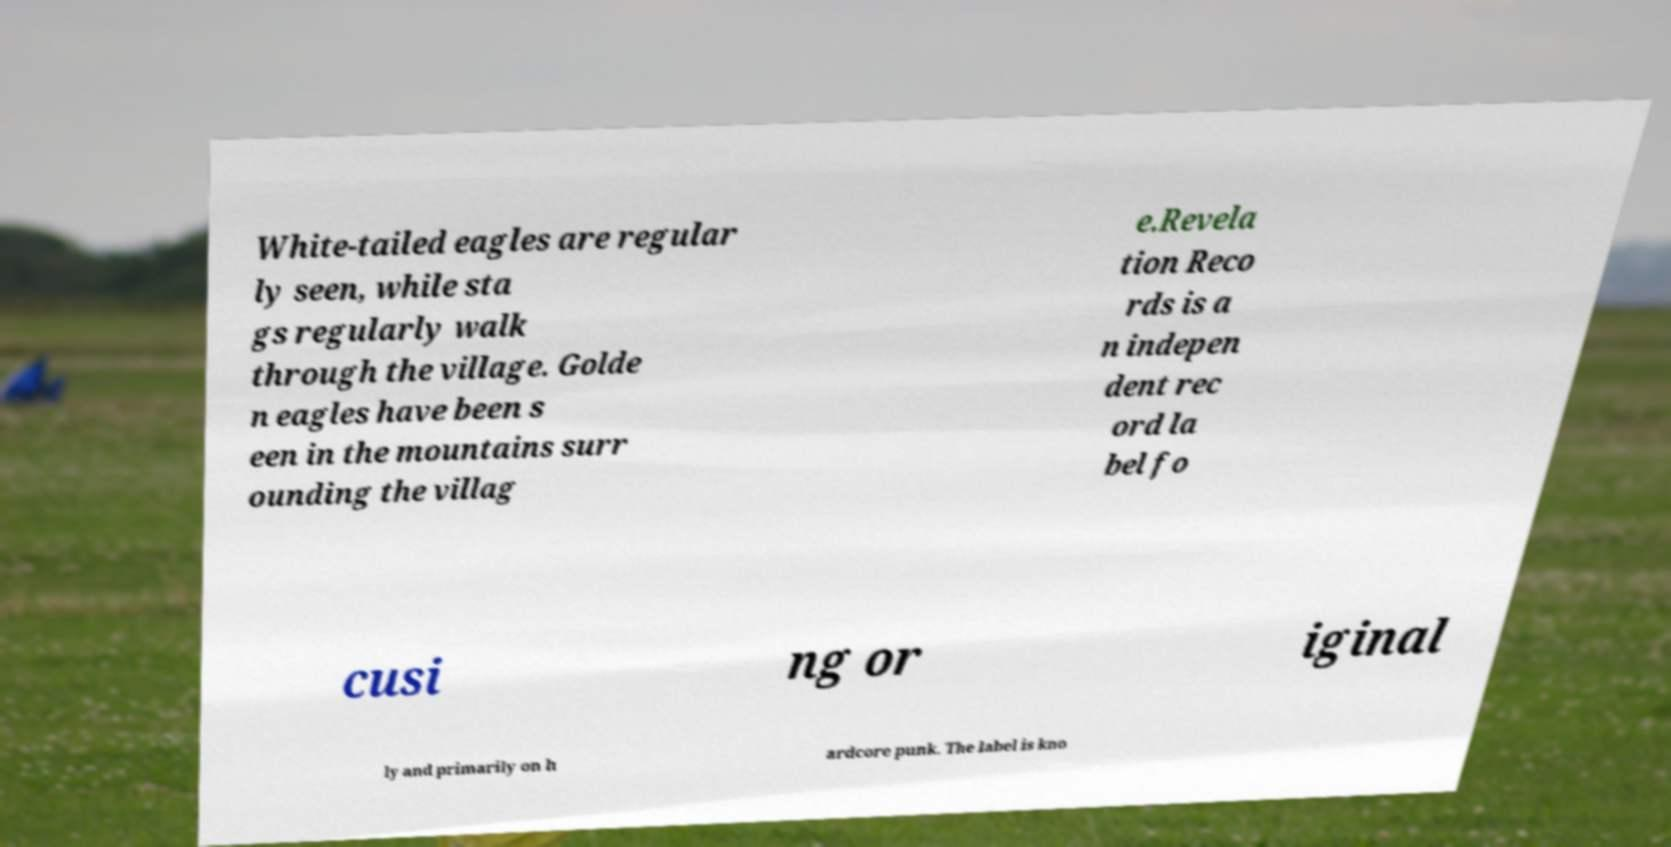Could you extract and type out the text from this image? White-tailed eagles are regular ly seen, while sta gs regularly walk through the village. Golde n eagles have been s een in the mountains surr ounding the villag e.Revela tion Reco rds is a n indepen dent rec ord la bel fo cusi ng or iginal ly and primarily on h ardcore punk. The label is kno 